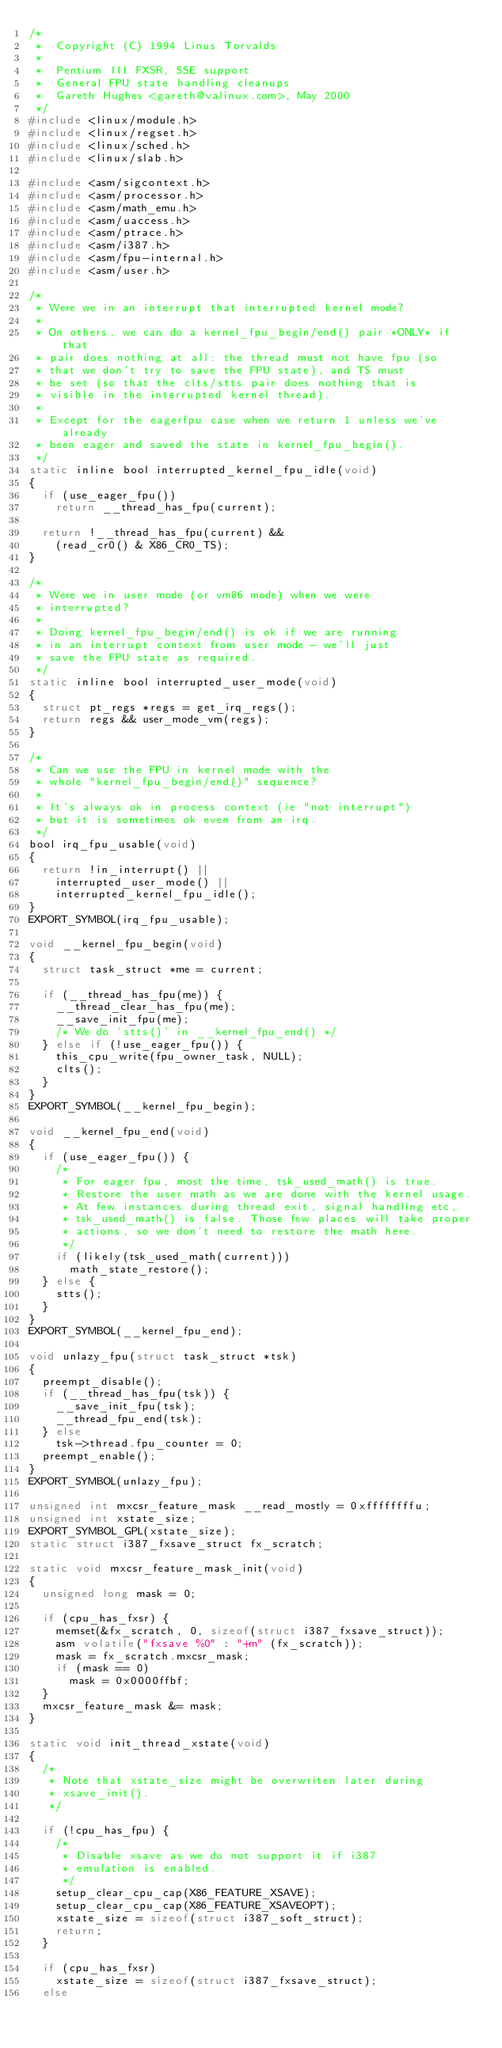<code> <loc_0><loc_0><loc_500><loc_500><_C_>/*
 *  Copyright (C) 1994 Linus Torvalds
 *
 *  Pentium III FXSR, SSE support
 *  General FPU state handling cleanups
 *	Gareth Hughes <gareth@valinux.com>, May 2000
 */
#include <linux/module.h>
#include <linux/regset.h>
#include <linux/sched.h>
#include <linux/slab.h>

#include <asm/sigcontext.h>
#include <asm/processor.h>
#include <asm/math_emu.h>
#include <asm/uaccess.h>
#include <asm/ptrace.h>
#include <asm/i387.h>
#include <asm/fpu-internal.h>
#include <asm/user.h>

/*
 * Were we in an interrupt that interrupted kernel mode?
 *
 * On others, we can do a kernel_fpu_begin/end() pair *ONLY* if that
 * pair does nothing at all: the thread must not have fpu (so
 * that we don't try to save the FPU state), and TS must
 * be set (so that the clts/stts pair does nothing that is
 * visible in the interrupted kernel thread).
 *
 * Except for the eagerfpu case when we return 1 unless we've already
 * been eager and saved the state in kernel_fpu_begin().
 */
static inline bool interrupted_kernel_fpu_idle(void)
{
	if (use_eager_fpu())
		return __thread_has_fpu(current);

	return !__thread_has_fpu(current) &&
		(read_cr0() & X86_CR0_TS);
}

/*
 * Were we in user mode (or vm86 mode) when we were
 * interrupted?
 *
 * Doing kernel_fpu_begin/end() is ok if we are running
 * in an interrupt context from user mode - we'll just
 * save the FPU state as required.
 */
static inline bool interrupted_user_mode(void)
{
	struct pt_regs *regs = get_irq_regs();
	return regs && user_mode_vm(regs);
}

/*
 * Can we use the FPU in kernel mode with the
 * whole "kernel_fpu_begin/end()" sequence?
 *
 * It's always ok in process context (ie "not interrupt")
 * but it is sometimes ok even from an irq.
 */
bool irq_fpu_usable(void)
{
	return !in_interrupt() ||
		interrupted_user_mode() ||
		interrupted_kernel_fpu_idle();
}
EXPORT_SYMBOL(irq_fpu_usable);

void __kernel_fpu_begin(void)
{
	struct task_struct *me = current;

	if (__thread_has_fpu(me)) {
		__thread_clear_has_fpu(me);
		__save_init_fpu(me);
		/* We do 'stts()' in __kernel_fpu_end() */
	} else if (!use_eager_fpu()) {
		this_cpu_write(fpu_owner_task, NULL);
		clts();
	}
}
EXPORT_SYMBOL(__kernel_fpu_begin);

void __kernel_fpu_end(void)
{
	if (use_eager_fpu()) {
		/*
		 * For eager fpu, most the time, tsk_used_math() is true.
		 * Restore the user math as we are done with the kernel usage.
		 * At few instances during thread exit, signal handling etc,
		 * tsk_used_math() is false. Those few places will take proper
		 * actions, so we don't need to restore the math here.
		 */
		if (likely(tsk_used_math(current)))
			math_state_restore();
	} else {
		stts();
	}
}
EXPORT_SYMBOL(__kernel_fpu_end);

void unlazy_fpu(struct task_struct *tsk)
{
	preempt_disable();
	if (__thread_has_fpu(tsk)) {
		__save_init_fpu(tsk);
		__thread_fpu_end(tsk);
	} else
		tsk->thread.fpu_counter = 0;
	preempt_enable();
}
EXPORT_SYMBOL(unlazy_fpu);

unsigned int mxcsr_feature_mask __read_mostly = 0xffffffffu;
unsigned int xstate_size;
EXPORT_SYMBOL_GPL(xstate_size);
static struct i387_fxsave_struct fx_scratch;

static void mxcsr_feature_mask_init(void)
{
	unsigned long mask = 0;

	if (cpu_has_fxsr) {
		memset(&fx_scratch, 0, sizeof(struct i387_fxsave_struct));
		asm volatile("fxsave %0" : "+m" (fx_scratch));
		mask = fx_scratch.mxcsr_mask;
		if (mask == 0)
			mask = 0x0000ffbf;
	}
	mxcsr_feature_mask &= mask;
}

static void init_thread_xstate(void)
{
	/*
	 * Note that xstate_size might be overwriten later during
	 * xsave_init().
	 */

	if (!cpu_has_fpu) {
		/*
		 * Disable xsave as we do not support it if i387
		 * emulation is enabled.
		 */
		setup_clear_cpu_cap(X86_FEATURE_XSAVE);
		setup_clear_cpu_cap(X86_FEATURE_XSAVEOPT);
		xstate_size = sizeof(struct i387_soft_struct);
		return;
	}

	if (cpu_has_fxsr)
		xstate_size = sizeof(struct i387_fxsave_struct);
	else</code> 